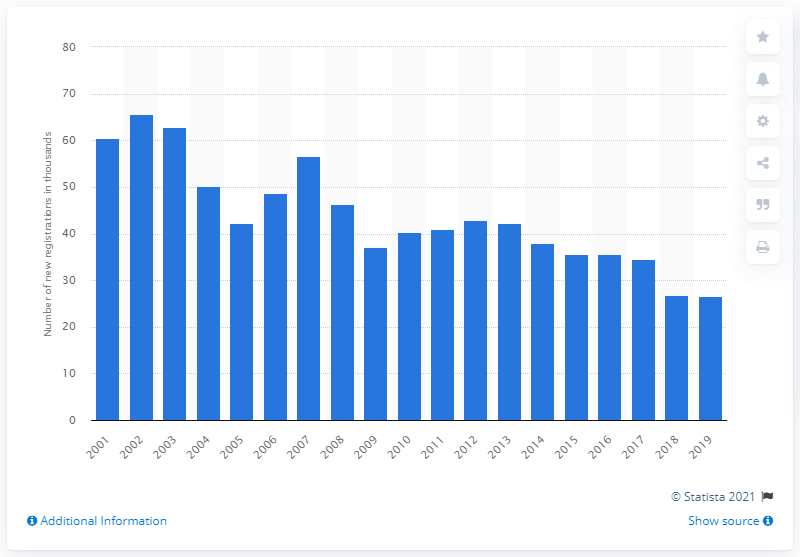Identify some key points in this picture. A peak in sales of the BMW 3 Series was observed in 2002. 